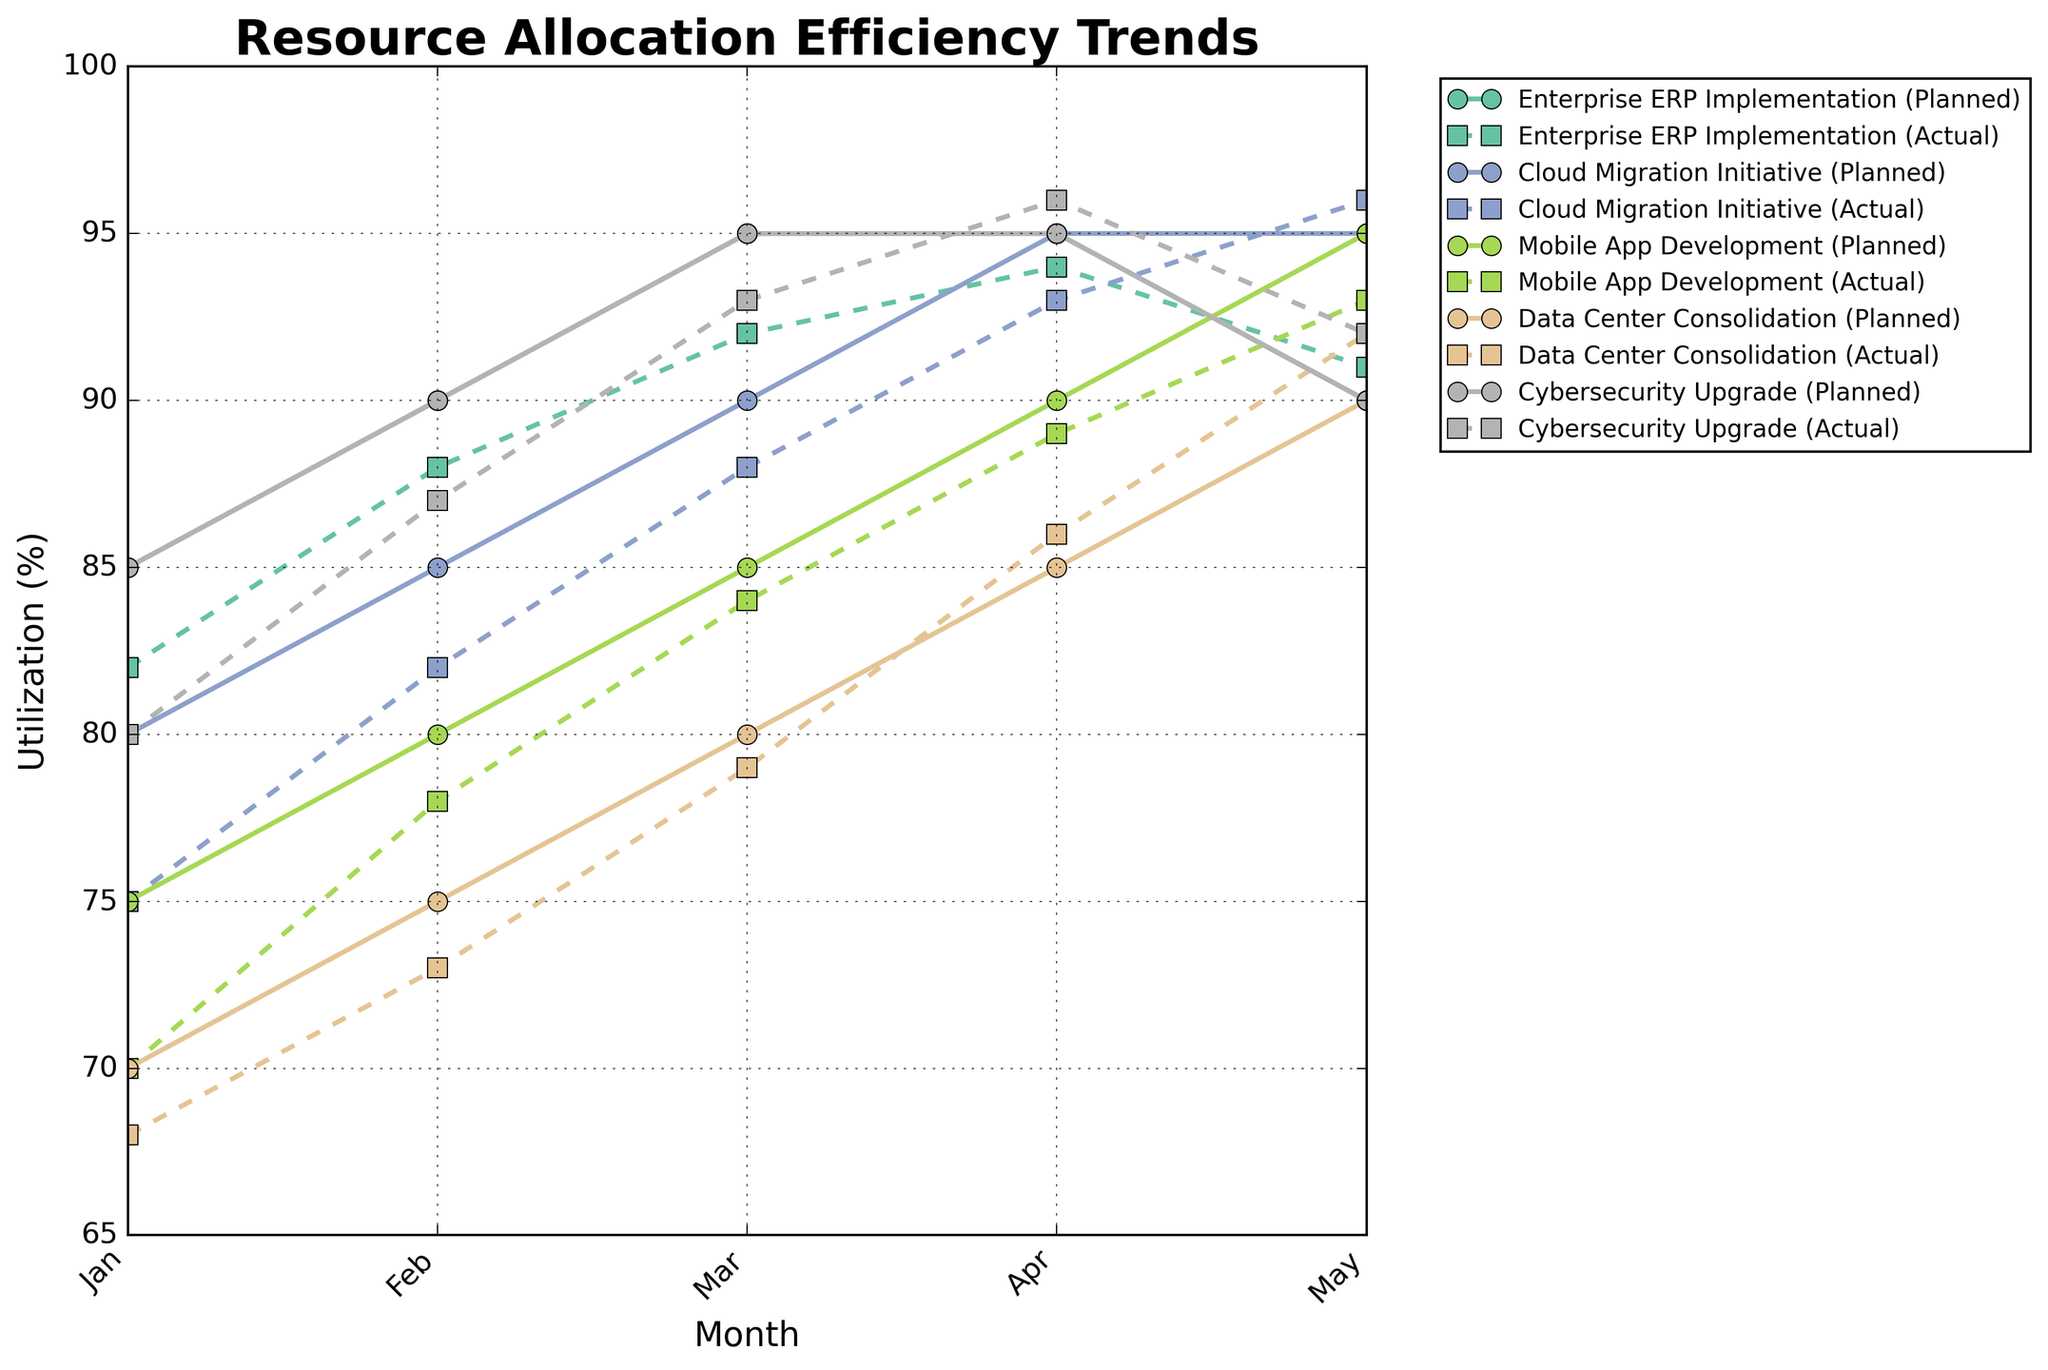What's the overall trend of resource allocation efficiency for the "Enterprise ERP Implementation" project across the months? To answer this, look at both the planned and actual utilization lines for "Enterprise ERP Implementation". They both show an overall increasing trend from January to April, then a slight decrease in May.
Answer: Increasing initially, slight decrease in May Which project had the highest actual utilization in May? Check the actual utilization values for May across all projects. "Cloud Migration Initiative" has an actual utilization of 96%, which is the highest.
Answer: Cloud Migration Initiative Compare the planned vs. actual utilization for "Mobile App Development" in March. What is the difference? Look at the values for March under "Mobile App Development". The planned utilization is 85%, and the actual utilization is 84%. The difference is 1%.
Answer: 1% In April, which project had a higher actual utilization: "Data Center Consolidation" or "Cybersecurity Upgrade"? Compare the actual utilization in April for both projects. "Data Center Consolidation" has 86% and "Cybersecurity Upgrade" has 96%.
Answer: Cybersecurity Upgrade Which month shows the smallest gap between planned utilization and actual utilization for "Enterprise ERP Implementation"? Check each month's difference for "Enterprise ERP Implementation". April shows a difference of only 1% (Planned: 95%, Actual: 94%).
Answer: April What is the average actual utilization for "Cloud Migration Initiative" across all months? Add up the actual utilization figures for each month (75 + 82 + 88 + 93 + 96 = 434) and divide by the number of months (5). The average is 434/5 = 86.8%.
Answer: 86.8% What visual color represents the "Enterprise ERP Implementation" in the chart? Identify the color used for the "Enterprise ERP Implementation" lines. Since the color is not explicitly stated, the chart should be checked visually.
Answer: Color used in the plot (likely green or a similar shade based on common palettes) Which project consistently had actual utilization lower than planned utilization across all months? Examine the differences between planned and actual utilization for each project and month. "Mobile App Development" consistently has actual utilization lower than planned across all months.
Answer: Mobile App Development In February, how does the actual utilization of "Cybersecurity Upgrade" compare to "Data Center Consolidation"? Compare the actual utilization figures for both projects in February. "Cybersecurity Upgrade" has 87% and "Data Center Consolidation" has 73%.
Answer: Higher for Cybersecurity Upgrade Calculate the total planned utilization for "Data Center Consolidation" over all months. Sum up the planned utilization percentages for "Data Center Consolidation" across all months (70 + 75 + 80 + 85 + 90 = 400).
Answer: 400 